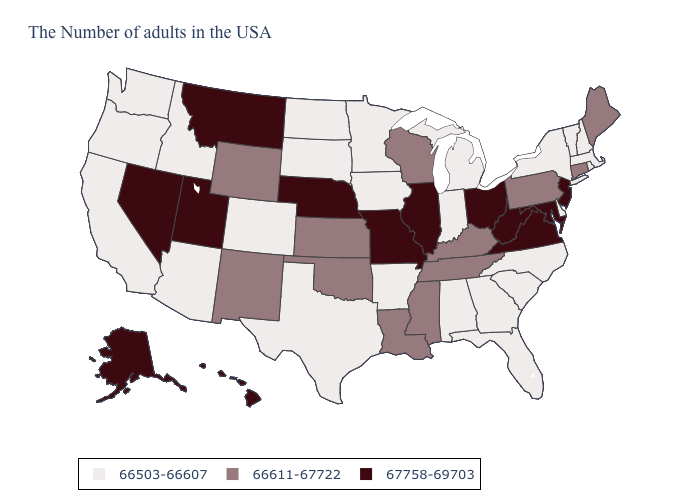What is the value of Alaska?
Be succinct. 67758-69703. Which states have the highest value in the USA?
Give a very brief answer. New Jersey, Maryland, Virginia, West Virginia, Ohio, Illinois, Missouri, Nebraska, Utah, Montana, Nevada, Alaska, Hawaii. Among the states that border Vermont , which have the highest value?
Write a very short answer. Massachusetts, New Hampshire, New York. What is the highest value in the USA?
Write a very short answer. 67758-69703. Name the states that have a value in the range 66611-67722?
Give a very brief answer. Maine, Connecticut, Pennsylvania, Kentucky, Tennessee, Wisconsin, Mississippi, Louisiana, Kansas, Oklahoma, Wyoming, New Mexico. Does Pennsylvania have the highest value in the Northeast?
Short answer required. No. Does the map have missing data?
Write a very short answer. No. Does Georgia have a lower value than Kentucky?
Short answer required. Yes. What is the value of New Hampshire?
Short answer required. 66503-66607. What is the highest value in the Northeast ?
Give a very brief answer. 67758-69703. Among the states that border Arkansas , which have the highest value?
Write a very short answer. Missouri. Among the states that border Arkansas , which have the highest value?
Concise answer only. Missouri. What is the lowest value in the West?
Concise answer only. 66503-66607. Name the states that have a value in the range 66611-67722?
Be succinct. Maine, Connecticut, Pennsylvania, Kentucky, Tennessee, Wisconsin, Mississippi, Louisiana, Kansas, Oklahoma, Wyoming, New Mexico. Among the states that border West Virginia , which have the highest value?
Concise answer only. Maryland, Virginia, Ohio. 